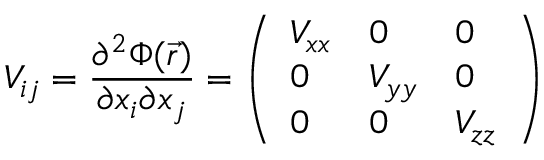<formula> <loc_0><loc_0><loc_500><loc_500>V _ { i j } = { \frac { \partial ^ { 2 } \Phi ( { \vec { r } } ) } { \partial x _ { i } \partial x _ { j } } } = { \left ( \begin{array} { l l l } { V _ { x x } } & { 0 } & { 0 } \\ { 0 } & { V _ { y y } } & { 0 } \\ { 0 } & { 0 } & { V _ { z z } } \end{array} \right ) }</formula> 